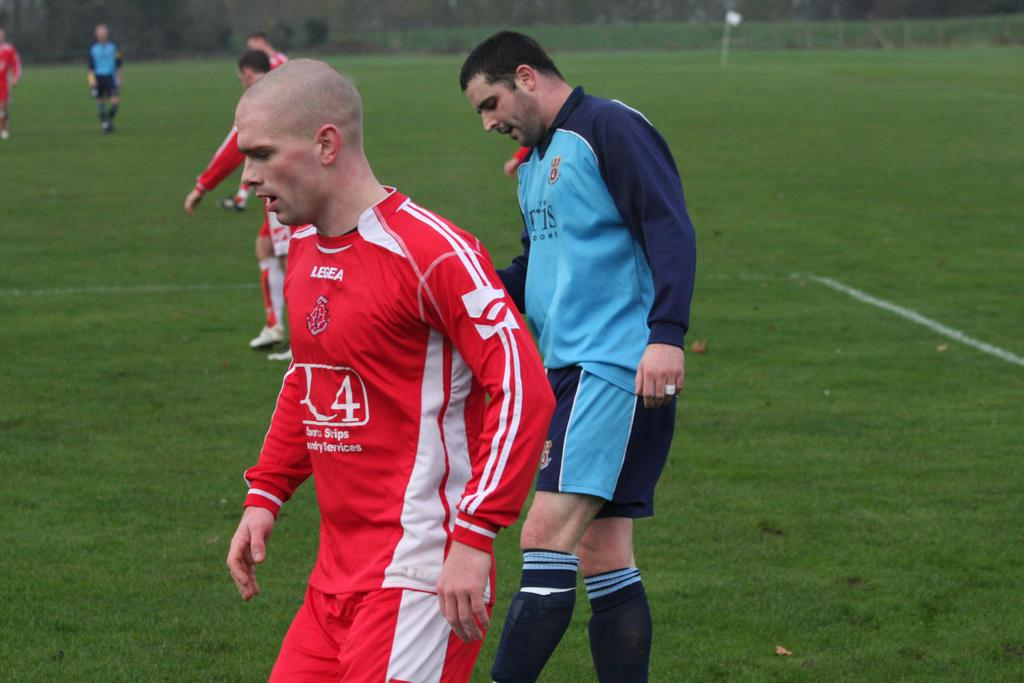What is happening in the image? There is a group of players in the image. What are the players doing? The players are walking on the ground. What colors are the dresses of the players? Some players are wearing blue dresses, and some are wearing red dresses. What type of gold mark can be seen on the players' dresses? There is no gold mark present on the players' dresses; the colors mentioned are blue and red. 